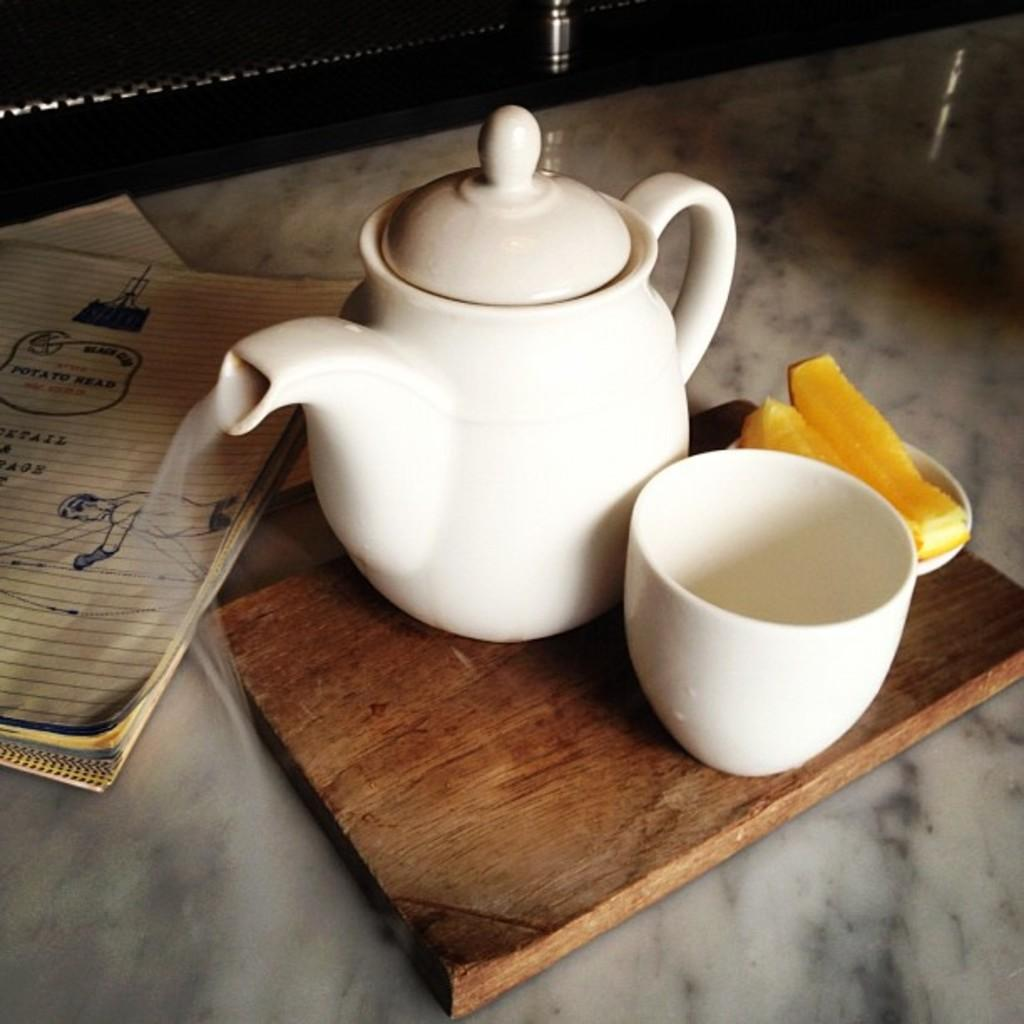What is on the floor in the image? There is a book and a wooden plank on the floor. What is on the wooden plank? There is a teapot, a cup, and a plate with food on the wooden plank. What type of surface is the book resting on? The book is resting on the floor. What might be used for serving or holding food in the image? The plate with food and the cup can be used for serving or holding food. What grade is the book on the floor? The grade of the book cannot be determined from the image, as books do not have grades. What statement does the teapot make in the image? The teapot does not make a statement in the image; it is an inanimate object. 